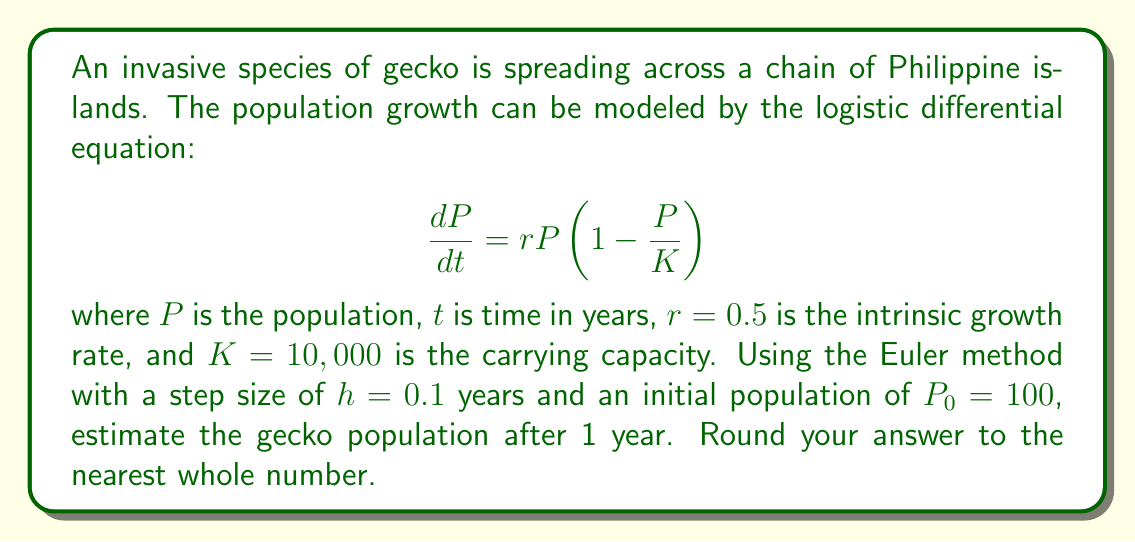Give your solution to this math problem. To solve this problem, we'll use the Euler method to numerically approximate the solution to the differential equation. The Euler method is given by:

$$P_{n+1} = P_n + h \cdot f(t_n, P_n)$$

where $f(t, P) = rP(1 - P/K)$ is the right-hand side of our differential equation.

Steps:
1) We need to iterate 10 times to cover 1 year (1 / 0.1 = 10 steps).
2) For each step, we'll calculate:
   $$P_{n+1} = P_n + 0.1 \cdot 0.5P_n(1 - P_n/10000)$$

Let's compute the first few steps:

Step 0: $P_0 = 100$
Step 1: $P_1 = 100 + 0.1 \cdot 0.5 \cdot 100(1 - 100/10000) = 104.95$
Step 2: $P_2 = 104.95 + 0.1 \cdot 0.5 \cdot 104.95(1 - 104.95/10000) = 110.15$

Continuing this process for 10 steps:

Step 3: $P_3 = 115.61$
Step 4: $P_4 = 121.34$
Step 5: $P_5 = 127.35$
Step 6: $P_6 = 133.66$
Step 7: $P_7 = 140.27$
Step 8: $P_8 = 147.20$
Step 9: $P_9 = 154.47$
Step 10: $P_{10} = 162.09$

Rounding to the nearest whole number, we get 162.
Answer: 162 